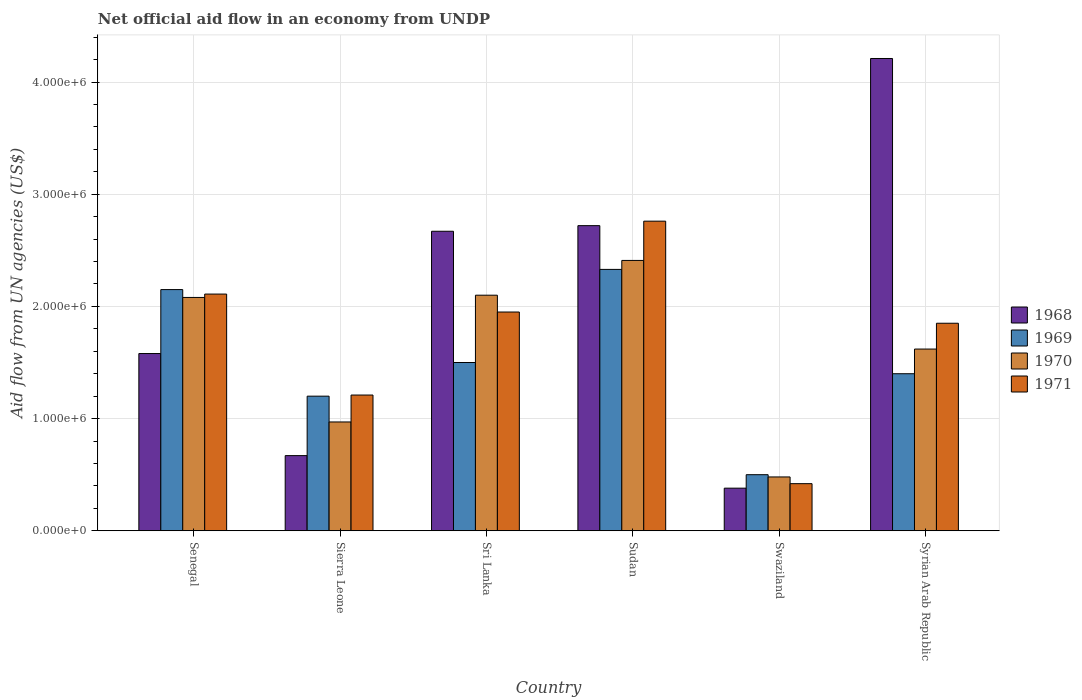Are the number of bars per tick equal to the number of legend labels?
Your response must be concise. Yes. Are the number of bars on each tick of the X-axis equal?
Give a very brief answer. Yes. How many bars are there on the 2nd tick from the left?
Your answer should be very brief. 4. How many bars are there on the 1st tick from the right?
Provide a succinct answer. 4. What is the label of the 5th group of bars from the left?
Keep it short and to the point. Swaziland. In how many cases, is the number of bars for a given country not equal to the number of legend labels?
Offer a very short reply. 0. What is the net official aid flow in 1968 in Syrian Arab Republic?
Keep it short and to the point. 4.21e+06. Across all countries, what is the maximum net official aid flow in 1970?
Give a very brief answer. 2.41e+06. Across all countries, what is the minimum net official aid flow in 1968?
Ensure brevity in your answer.  3.80e+05. In which country was the net official aid flow in 1971 maximum?
Offer a terse response. Sudan. In which country was the net official aid flow in 1971 minimum?
Provide a succinct answer. Swaziland. What is the total net official aid flow in 1968 in the graph?
Ensure brevity in your answer.  1.22e+07. What is the difference between the net official aid flow in 1968 in Sri Lanka and that in Swaziland?
Ensure brevity in your answer.  2.29e+06. What is the difference between the net official aid flow in 1969 in Swaziland and the net official aid flow in 1970 in Sudan?
Your answer should be compact. -1.91e+06. What is the average net official aid flow in 1968 per country?
Make the answer very short. 2.04e+06. What is the difference between the net official aid flow of/in 1970 and net official aid flow of/in 1968 in Swaziland?
Offer a terse response. 1.00e+05. What is the ratio of the net official aid flow in 1970 in Sudan to that in Syrian Arab Republic?
Make the answer very short. 1.49. What is the difference between the highest and the lowest net official aid flow in 1971?
Ensure brevity in your answer.  2.34e+06. In how many countries, is the net official aid flow in 1971 greater than the average net official aid flow in 1971 taken over all countries?
Offer a terse response. 4. What does the 3rd bar from the right in Syrian Arab Republic represents?
Make the answer very short. 1969. Is it the case that in every country, the sum of the net official aid flow in 1971 and net official aid flow in 1970 is greater than the net official aid flow in 1969?
Offer a very short reply. Yes. Are all the bars in the graph horizontal?
Your answer should be very brief. No. Are the values on the major ticks of Y-axis written in scientific E-notation?
Provide a short and direct response. Yes. Does the graph contain grids?
Make the answer very short. Yes. How many legend labels are there?
Offer a very short reply. 4. What is the title of the graph?
Your answer should be compact. Net official aid flow in an economy from UNDP. Does "2014" appear as one of the legend labels in the graph?
Provide a succinct answer. No. What is the label or title of the Y-axis?
Your answer should be compact. Aid flow from UN agencies (US$). What is the Aid flow from UN agencies (US$) in 1968 in Senegal?
Your response must be concise. 1.58e+06. What is the Aid flow from UN agencies (US$) of 1969 in Senegal?
Offer a terse response. 2.15e+06. What is the Aid flow from UN agencies (US$) in 1970 in Senegal?
Your answer should be very brief. 2.08e+06. What is the Aid flow from UN agencies (US$) in 1971 in Senegal?
Your response must be concise. 2.11e+06. What is the Aid flow from UN agencies (US$) of 1968 in Sierra Leone?
Provide a short and direct response. 6.70e+05. What is the Aid flow from UN agencies (US$) of 1969 in Sierra Leone?
Your response must be concise. 1.20e+06. What is the Aid flow from UN agencies (US$) in 1970 in Sierra Leone?
Make the answer very short. 9.70e+05. What is the Aid flow from UN agencies (US$) of 1971 in Sierra Leone?
Your answer should be very brief. 1.21e+06. What is the Aid flow from UN agencies (US$) of 1968 in Sri Lanka?
Your answer should be very brief. 2.67e+06. What is the Aid flow from UN agencies (US$) of 1969 in Sri Lanka?
Provide a short and direct response. 1.50e+06. What is the Aid flow from UN agencies (US$) of 1970 in Sri Lanka?
Ensure brevity in your answer.  2.10e+06. What is the Aid flow from UN agencies (US$) of 1971 in Sri Lanka?
Your answer should be very brief. 1.95e+06. What is the Aid flow from UN agencies (US$) of 1968 in Sudan?
Make the answer very short. 2.72e+06. What is the Aid flow from UN agencies (US$) of 1969 in Sudan?
Provide a succinct answer. 2.33e+06. What is the Aid flow from UN agencies (US$) of 1970 in Sudan?
Keep it short and to the point. 2.41e+06. What is the Aid flow from UN agencies (US$) in 1971 in Sudan?
Your response must be concise. 2.76e+06. What is the Aid flow from UN agencies (US$) of 1968 in Swaziland?
Keep it short and to the point. 3.80e+05. What is the Aid flow from UN agencies (US$) of 1969 in Swaziland?
Give a very brief answer. 5.00e+05. What is the Aid flow from UN agencies (US$) of 1970 in Swaziland?
Keep it short and to the point. 4.80e+05. What is the Aid flow from UN agencies (US$) in 1968 in Syrian Arab Republic?
Your answer should be compact. 4.21e+06. What is the Aid flow from UN agencies (US$) of 1969 in Syrian Arab Republic?
Provide a short and direct response. 1.40e+06. What is the Aid flow from UN agencies (US$) in 1970 in Syrian Arab Republic?
Offer a very short reply. 1.62e+06. What is the Aid flow from UN agencies (US$) in 1971 in Syrian Arab Republic?
Provide a short and direct response. 1.85e+06. Across all countries, what is the maximum Aid flow from UN agencies (US$) of 1968?
Offer a very short reply. 4.21e+06. Across all countries, what is the maximum Aid flow from UN agencies (US$) of 1969?
Give a very brief answer. 2.33e+06. Across all countries, what is the maximum Aid flow from UN agencies (US$) of 1970?
Ensure brevity in your answer.  2.41e+06. Across all countries, what is the maximum Aid flow from UN agencies (US$) of 1971?
Make the answer very short. 2.76e+06. Across all countries, what is the minimum Aid flow from UN agencies (US$) of 1968?
Provide a succinct answer. 3.80e+05. Across all countries, what is the minimum Aid flow from UN agencies (US$) in 1971?
Offer a very short reply. 4.20e+05. What is the total Aid flow from UN agencies (US$) in 1968 in the graph?
Offer a terse response. 1.22e+07. What is the total Aid flow from UN agencies (US$) of 1969 in the graph?
Offer a very short reply. 9.08e+06. What is the total Aid flow from UN agencies (US$) in 1970 in the graph?
Your answer should be very brief. 9.66e+06. What is the total Aid flow from UN agencies (US$) in 1971 in the graph?
Give a very brief answer. 1.03e+07. What is the difference between the Aid flow from UN agencies (US$) in 1968 in Senegal and that in Sierra Leone?
Keep it short and to the point. 9.10e+05. What is the difference between the Aid flow from UN agencies (US$) in 1969 in Senegal and that in Sierra Leone?
Your answer should be compact. 9.50e+05. What is the difference between the Aid flow from UN agencies (US$) of 1970 in Senegal and that in Sierra Leone?
Make the answer very short. 1.11e+06. What is the difference between the Aid flow from UN agencies (US$) in 1971 in Senegal and that in Sierra Leone?
Your answer should be compact. 9.00e+05. What is the difference between the Aid flow from UN agencies (US$) in 1968 in Senegal and that in Sri Lanka?
Ensure brevity in your answer.  -1.09e+06. What is the difference between the Aid flow from UN agencies (US$) of 1969 in Senegal and that in Sri Lanka?
Offer a very short reply. 6.50e+05. What is the difference between the Aid flow from UN agencies (US$) in 1968 in Senegal and that in Sudan?
Your response must be concise. -1.14e+06. What is the difference between the Aid flow from UN agencies (US$) in 1970 in Senegal and that in Sudan?
Your answer should be compact. -3.30e+05. What is the difference between the Aid flow from UN agencies (US$) of 1971 in Senegal and that in Sudan?
Offer a terse response. -6.50e+05. What is the difference between the Aid flow from UN agencies (US$) of 1968 in Senegal and that in Swaziland?
Your answer should be very brief. 1.20e+06. What is the difference between the Aid flow from UN agencies (US$) in 1969 in Senegal and that in Swaziland?
Your answer should be very brief. 1.65e+06. What is the difference between the Aid flow from UN agencies (US$) in 1970 in Senegal and that in Swaziland?
Your answer should be very brief. 1.60e+06. What is the difference between the Aid flow from UN agencies (US$) in 1971 in Senegal and that in Swaziland?
Your answer should be very brief. 1.69e+06. What is the difference between the Aid flow from UN agencies (US$) in 1968 in Senegal and that in Syrian Arab Republic?
Provide a short and direct response. -2.63e+06. What is the difference between the Aid flow from UN agencies (US$) of 1969 in Senegal and that in Syrian Arab Republic?
Your answer should be very brief. 7.50e+05. What is the difference between the Aid flow from UN agencies (US$) in 1970 in Senegal and that in Syrian Arab Republic?
Ensure brevity in your answer.  4.60e+05. What is the difference between the Aid flow from UN agencies (US$) of 1971 in Senegal and that in Syrian Arab Republic?
Provide a succinct answer. 2.60e+05. What is the difference between the Aid flow from UN agencies (US$) of 1968 in Sierra Leone and that in Sri Lanka?
Provide a succinct answer. -2.00e+06. What is the difference between the Aid flow from UN agencies (US$) of 1969 in Sierra Leone and that in Sri Lanka?
Your response must be concise. -3.00e+05. What is the difference between the Aid flow from UN agencies (US$) in 1970 in Sierra Leone and that in Sri Lanka?
Your answer should be compact. -1.13e+06. What is the difference between the Aid flow from UN agencies (US$) in 1971 in Sierra Leone and that in Sri Lanka?
Give a very brief answer. -7.40e+05. What is the difference between the Aid flow from UN agencies (US$) in 1968 in Sierra Leone and that in Sudan?
Your answer should be compact. -2.05e+06. What is the difference between the Aid flow from UN agencies (US$) of 1969 in Sierra Leone and that in Sudan?
Make the answer very short. -1.13e+06. What is the difference between the Aid flow from UN agencies (US$) of 1970 in Sierra Leone and that in Sudan?
Provide a succinct answer. -1.44e+06. What is the difference between the Aid flow from UN agencies (US$) of 1971 in Sierra Leone and that in Sudan?
Your answer should be very brief. -1.55e+06. What is the difference between the Aid flow from UN agencies (US$) of 1971 in Sierra Leone and that in Swaziland?
Offer a very short reply. 7.90e+05. What is the difference between the Aid flow from UN agencies (US$) of 1968 in Sierra Leone and that in Syrian Arab Republic?
Ensure brevity in your answer.  -3.54e+06. What is the difference between the Aid flow from UN agencies (US$) of 1970 in Sierra Leone and that in Syrian Arab Republic?
Ensure brevity in your answer.  -6.50e+05. What is the difference between the Aid flow from UN agencies (US$) of 1971 in Sierra Leone and that in Syrian Arab Republic?
Provide a succinct answer. -6.40e+05. What is the difference between the Aid flow from UN agencies (US$) in 1968 in Sri Lanka and that in Sudan?
Your answer should be compact. -5.00e+04. What is the difference between the Aid flow from UN agencies (US$) of 1969 in Sri Lanka and that in Sudan?
Ensure brevity in your answer.  -8.30e+05. What is the difference between the Aid flow from UN agencies (US$) of 1970 in Sri Lanka and that in Sudan?
Offer a very short reply. -3.10e+05. What is the difference between the Aid flow from UN agencies (US$) of 1971 in Sri Lanka and that in Sudan?
Provide a short and direct response. -8.10e+05. What is the difference between the Aid flow from UN agencies (US$) in 1968 in Sri Lanka and that in Swaziland?
Offer a very short reply. 2.29e+06. What is the difference between the Aid flow from UN agencies (US$) in 1969 in Sri Lanka and that in Swaziland?
Give a very brief answer. 1.00e+06. What is the difference between the Aid flow from UN agencies (US$) in 1970 in Sri Lanka and that in Swaziland?
Provide a short and direct response. 1.62e+06. What is the difference between the Aid flow from UN agencies (US$) in 1971 in Sri Lanka and that in Swaziland?
Your answer should be very brief. 1.53e+06. What is the difference between the Aid flow from UN agencies (US$) in 1968 in Sri Lanka and that in Syrian Arab Republic?
Give a very brief answer. -1.54e+06. What is the difference between the Aid flow from UN agencies (US$) in 1970 in Sri Lanka and that in Syrian Arab Republic?
Give a very brief answer. 4.80e+05. What is the difference between the Aid flow from UN agencies (US$) of 1968 in Sudan and that in Swaziland?
Give a very brief answer. 2.34e+06. What is the difference between the Aid flow from UN agencies (US$) of 1969 in Sudan and that in Swaziland?
Provide a succinct answer. 1.83e+06. What is the difference between the Aid flow from UN agencies (US$) in 1970 in Sudan and that in Swaziland?
Your answer should be compact. 1.93e+06. What is the difference between the Aid flow from UN agencies (US$) of 1971 in Sudan and that in Swaziland?
Provide a succinct answer. 2.34e+06. What is the difference between the Aid flow from UN agencies (US$) in 1968 in Sudan and that in Syrian Arab Republic?
Keep it short and to the point. -1.49e+06. What is the difference between the Aid flow from UN agencies (US$) of 1969 in Sudan and that in Syrian Arab Republic?
Provide a succinct answer. 9.30e+05. What is the difference between the Aid flow from UN agencies (US$) of 1970 in Sudan and that in Syrian Arab Republic?
Your answer should be compact. 7.90e+05. What is the difference between the Aid flow from UN agencies (US$) in 1971 in Sudan and that in Syrian Arab Republic?
Ensure brevity in your answer.  9.10e+05. What is the difference between the Aid flow from UN agencies (US$) of 1968 in Swaziland and that in Syrian Arab Republic?
Provide a short and direct response. -3.83e+06. What is the difference between the Aid flow from UN agencies (US$) in 1969 in Swaziland and that in Syrian Arab Republic?
Offer a very short reply. -9.00e+05. What is the difference between the Aid flow from UN agencies (US$) of 1970 in Swaziland and that in Syrian Arab Republic?
Give a very brief answer. -1.14e+06. What is the difference between the Aid flow from UN agencies (US$) of 1971 in Swaziland and that in Syrian Arab Republic?
Provide a succinct answer. -1.43e+06. What is the difference between the Aid flow from UN agencies (US$) of 1968 in Senegal and the Aid flow from UN agencies (US$) of 1969 in Sierra Leone?
Give a very brief answer. 3.80e+05. What is the difference between the Aid flow from UN agencies (US$) of 1968 in Senegal and the Aid flow from UN agencies (US$) of 1970 in Sierra Leone?
Your response must be concise. 6.10e+05. What is the difference between the Aid flow from UN agencies (US$) of 1969 in Senegal and the Aid flow from UN agencies (US$) of 1970 in Sierra Leone?
Provide a succinct answer. 1.18e+06. What is the difference between the Aid flow from UN agencies (US$) of 1969 in Senegal and the Aid flow from UN agencies (US$) of 1971 in Sierra Leone?
Your response must be concise. 9.40e+05. What is the difference between the Aid flow from UN agencies (US$) in 1970 in Senegal and the Aid flow from UN agencies (US$) in 1971 in Sierra Leone?
Your response must be concise. 8.70e+05. What is the difference between the Aid flow from UN agencies (US$) in 1968 in Senegal and the Aid flow from UN agencies (US$) in 1969 in Sri Lanka?
Ensure brevity in your answer.  8.00e+04. What is the difference between the Aid flow from UN agencies (US$) of 1968 in Senegal and the Aid flow from UN agencies (US$) of 1970 in Sri Lanka?
Provide a short and direct response. -5.20e+05. What is the difference between the Aid flow from UN agencies (US$) of 1968 in Senegal and the Aid flow from UN agencies (US$) of 1971 in Sri Lanka?
Provide a succinct answer. -3.70e+05. What is the difference between the Aid flow from UN agencies (US$) in 1969 in Senegal and the Aid flow from UN agencies (US$) in 1970 in Sri Lanka?
Provide a short and direct response. 5.00e+04. What is the difference between the Aid flow from UN agencies (US$) of 1969 in Senegal and the Aid flow from UN agencies (US$) of 1971 in Sri Lanka?
Keep it short and to the point. 2.00e+05. What is the difference between the Aid flow from UN agencies (US$) in 1970 in Senegal and the Aid flow from UN agencies (US$) in 1971 in Sri Lanka?
Make the answer very short. 1.30e+05. What is the difference between the Aid flow from UN agencies (US$) in 1968 in Senegal and the Aid flow from UN agencies (US$) in 1969 in Sudan?
Make the answer very short. -7.50e+05. What is the difference between the Aid flow from UN agencies (US$) of 1968 in Senegal and the Aid flow from UN agencies (US$) of 1970 in Sudan?
Provide a short and direct response. -8.30e+05. What is the difference between the Aid flow from UN agencies (US$) in 1968 in Senegal and the Aid flow from UN agencies (US$) in 1971 in Sudan?
Your answer should be compact. -1.18e+06. What is the difference between the Aid flow from UN agencies (US$) in 1969 in Senegal and the Aid flow from UN agencies (US$) in 1971 in Sudan?
Offer a very short reply. -6.10e+05. What is the difference between the Aid flow from UN agencies (US$) of 1970 in Senegal and the Aid flow from UN agencies (US$) of 1971 in Sudan?
Your response must be concise. -6.80e+05. What is the difference between the Aid flow from UN agencies (US$) of 1968 in Senegal and the Aid flow from UN agencies (US$) of 1969 in Swaziland?
Your answer should be compact. 1.08e+06. What is the difference between the Aid flow from UN agencies (US$) in 1968 in Senegal and the Aid flow from UN agencies (US$) in 1970 in Swaziland?
Your response must be concise. 1.10e+06. What is the difference between the Aid flow from UN agencies (US$) in 1968 in Senegal and the Aid flow from UN agencies (US$) in 1971 in Swaziland?
Your answer should be very brief. 1.16e+06. What is the difference between the Aid flow from UN agencies (US$) in 1969 in Senegal and the Aid flow from UN agencies (US$) in 1970 in Swaziland?
Offer a very short reply. 1.67e+06. What is the difference between the Aid flow from UN agencies (US$) in 1969 in Senegal and the Aid flow from UN agencies (US$) in 1971 in Swaziland?
Your answer should be very brief. 1.73e+06. What is the difference between the Aid flow from UN agencies (US$) of 1970 in Senegal and the Aid flow from UN agencies (US$) of 1971 in Swaziland?
Keep it short and to the point. 1.66e+06. What is the difference between the Aid flow from UN agencies (US$) of 1968 in Senegal and the Aid flow from UN agencies (US$) of 1971 in Syrian Arab Republic?
Offer a very short reply. -2.70e+05. What is the difference between the Aid flow from UN agencies (US$) of 1969 in Senegal and the Aid flow from UN agencies (US$) of 1970 in Syrian Arab Republic?
Keep it short and to the point. 5.30e+05. What is the difference between the Aid flow from UN agencies (US$) in 1969 in Senegal and the Aid flow from UN agencies (US$) in 1971 in Syrian Arab Republic?
Offer a terse response. 3.00e+05. What is the difference between the Aid flow from UN agencies (US$) of 1970 in Senegal and the Aid flow from UN agencies (US$) of 1971 in Syrian Arab Republic?
Offer a terse response. 2.30e+05. What is the difference between the Aid flow from UN agencies (US$) of 1968 in Sierra Leone and the Aid flow from UN agencies (US$) of 1969 in Sri Lanka?
Your answer should be very brief. -8.30e+05. What is the difference between the Aid flow from UN agencies (US$) in 1968 in Sierra Leone and the Aid flow from UN agencies (US$) in 1970 in Sri Lanka?
Provide a succinct answer. -1.43e+06. What is the difference between the Aid flow from UN agencies (US$) in 1968 in Sierra Leone and the Aid flow from UN agencies (US$) in 1971 in Sri Lanka?
Provide a short and direct response. -1.28e+06. What is the difference between the Aid flow from UN agencies (US$) in 1969 in Sierra Leone and the Aid flow from UN agencies (US$) in 1970 in Sri Lanka?
Your response must be concise. -9.00e+05. What is the difference between the Aid flow from UN agencies (US$) in 1969 in Sierra Leone and the Aid flow from UN agencies (US$) in 1971 in Sri Lanka?
Give a very brief answer. -7.50e+05. What is the difference between the Aid flow from UN agencies (US$) of 1970 in Sierra Leone and the Aid flow from UN agencies (US$) of 1971 in Sri Lanka?
Give a very brief answer. -9.80e+05. What is the difference between the Aid flow from UN agencies (US$) of 1968 in Sierra Leone and the Aid flow from UN agencies (US$) of 1969 in Sudan?
Provide a succinct answer. -1.66e+06. What is the difference between the Aid flow from UN agencies (US$) of 1968 in Sierra Leone and the Aid flow from UN agencies (US$) of 1970 in Sudan?
Your response must be concise. -1.74e+06. What is the difference between the Aid flow from UN agencies (US$) of 1968 in Sierra Leone and the Aid flow from UN agencies (US$) of 1971 in Sudan?
Provide a succinct answer. -2.09e+06. What is the difference between the Aid flow from UN agencies (US$) of 1969 in Sierra Leone and the Aid flow from UN agencies (US$) of 1970 in Sudan?
Your response must be concise. -1.21e+06. What is the difference between the Aid flow from UN agencies (US$) of 1969 in Sierra Leone and the Aid flow from UN agencies (US$) of 1971 in Sudan?
Make the answer very short. -1.56e+06. What is the difference between the Aid flow from UN agencies (US$) of 1970 in Sierra Leone and the Aid flow from UN agencies (US$) of 1971 in Sudan?
Your answer should be compact. -1.79e+06. What is the difference between the Aid flow from UN agencies (US$) in 1968 in Sierra Leone and the Aid flow from UN agencies (US$) in 1971 in Swaziland?
Provide a succinct answer. 2.50e+05. What is the difference between the Aid flow from UN agencies (US$) in 1969 in Sierra Leone and the Aid flow from UN agencies (US$) in 1970 in Swaziland?
Offer a very short reply. 7.20e+05. What is the difference between the Aid flow from UN agencies (US$) of 1969 in Sierra Leone and the Aid flow from UN agencies (US$) of 1971 in Swaziland?
Offer a very short reply. 7.80e+05. What is the difference between the Aid flow from UN agencies (US$) of 1968 in Sierra Leone and the Aid flow from UN agencies (US$) of 1969 in Syrian Arab Republic?
Make the answer very short. -7.30e+05. What is the difference between the Aid flow from UN agencies (US$) in 1968 in Sierra Leone and the Aid flow from UN agencies (US$) in 1970 in Syrian Arab Republic?
Ensure brevity in your answer.  -9.50e+05. What is the difference between the Aid flow from UN agencies (US$) in 1968 in Sierra Leone and the Aid flow from UN agencies (US$) in 1971 in Syrian Arab Republic?
Offer a very short reply. -1.18e+06. What is the difference between the Aid flow from UN agencies (US$) of 1969 in Sierra Leone and the Aid flow from UN agencies (US$) of 1970 in Syrian Arab Republic?
Ensure brevity in your answer.  -4.20e+05. What is the difference between the Aid flow from UN agencies (US$) of 1969 in Sierra Leone and the Aid flow from UN agencies (US$) of 1971 in Syrian Arab Republic?
Your response must be concise. -6.50e+05. What is the difference between the Aid flow from UN agencies (US$) of 1970 in Sierra Leone and the Aid flow from UN agencies (US$) of 1971 in Syrian Arab Republic?
Ensure brevity in your answer.  -8.80e+05. What is the difference between the Aid flow from UN agencies (US$) of 1968 in Sri Lanka and the Aid flow from UN agencies (US$) of 1969 in Sudan?
Your response must be concise. 3.40e+05. What is the difference between the Aid flow from UN agencies (US$) in 1969 in Sri Lanka and the Aid flow from UN agencies (US$) in 1970 in Sudan?
Keep it short and to the point. -9.10e+05. What is the difference between the Aid flow from UN agencies (US$) in 1969 in Sri Lanka and the Aid flow from UN agencies (US$) in 1971 in Sudan?
Ensure brevity in your answer.  -1.26e+06. What is the difference between the Aid flow from UN agencies (US$) of 1970 in Sri Lanka and the Aid flow from UN agencies (US$) of 1971 in Sudan?
Provide a succinct answer. -6.60e+05. What is the difference between the Aid flow from UN agencies (US$) in 1968 in Sri Lanka and the Aid flow from UN agencies (US$) in 1969 in Swaziland?
Offer a very short reply. 2.17e+06. What is the difference between the Aid flow from UN agencies (US$) of 1968 in Sri Lanka and the Aid flow from UN agencies (US$) of 1970 in Swaziland?
Make the answer very short. 2.19e+06. What is the difference between the Aid flow from UN agencies (US$) of 1968 in Sri Lanka and the Aid flow from UN agencies (US$) of 1971 in Swaziland?
Ensure brevity in your answer.  2.25e+06. What is the difference between the Aid flow from UN agencies (US$) in 1969 in Sri Lanka and the Aid flow from UN agencies (US$) in 1970 in Swaziland?
Your response must be concise. 1.02e+06. What is the difference between the Aid flow from UN agencies (US$) of 1969 in Sri Lanka and the Aid flow from UN agencies (US$) of 1971 in Swaziland?
Provide a succinct answer. 1.08e+06. What is the difference between the Aid flow from UN agencies (US$) in 1970 in Sri Lanka and the Aid flow from UN agencies (US$) in 1971 in Swaziland?
Offer a very short reply. 1.68e+06. What is the difference between the Aid flow from UN agencies (US$) of 1968 in Sri Lanka and the Aid flow from UN agencies (US$) of 1969 in Syrian Arab Republic?
Give a very brief answer. 1.27e+06. What is the difference between the Aid flow from UN agencies (US$) of 1968 in Sri Lanka and the Aid flow from UN agencies (US$) of 1970 in Syrian Arab Republic?
Provide a short and direct response. 1.05e+06. What is the difference between the Aid flow from UN agencies (US$) in 1968 in Sri Lanka and the Aid flow from UN agencies (US$) in 1971 in Syrian Arab Republic?
Your response must be concise. 8.20e+05. What is the difference between the Aid flow from UN agencies (US$) of 1969 in Sri Lanka and the Aid flow from UN agencies (US$) of 1970 in Syrian Arab Republic?
Your response must be concise. -1.20e+05. What is the difference between the Aid flow from UN agencies (US$) of 1969 in Sri Lanka and the Aid flow from UN agencies (US$) of 1971 in Syrian Arab Republic?
Provide a succinct answer. -3.50e+05. What is the difference between the Aid flow from UN agencies (US$) in 1968 in Sudan and the Aid flow from UN agencies (US$) in 1969 in Swaziland?
Offer a terse response. 2.22e+06. What is the difference between the Aid flow from UN agencies (US$) in 1968 in Sudan and the Aid flow from UN agencies (US$) in 1970 in Swaziland?
Keep it short and to the point. 2.24e+06. What is the difference between the Aid flow from UN agencies (US$) in 1968 in Sudan and the Aid flow from UN agencies (US$) in 1971 in Swaziland?
Give a very brief answer. 2.30e+06. What is the difference between the Aid flow from UN agencies (US$) of 1969 in Sudan and the Aid flow from UN agencies (US$) of 1970 in Swaziland?
Your answer should be very brief. 1.85e+06. What is the difference between the Aid flow from UN agencies (US$) of 1969 in Sudan and the Aid flow from UN agencies (US$) of 1971 in Swaziland?
Give a very brief answer. 1.91e+06. What is the difference between the Aid flow from UN agencies (US$) in 1970 in Sudan and the Aid flow from UN agencies (US$) in 1971 in Swaziland?
Provide a short and direct response. 1.99e+06. What is the difference between the Aid flow from UN agencies (US$) of 1968 in Sudan and the Aid flow from UN agencies (US$) of 1969 in Syrian Arab Republic?
Provide a short and direct response. 1.32e+06. What is the difference between the Aid flow from UN agencies (US$) of 1968 in Sudan and the Aid flow from UN agencies (US$) of 1970 in Syrian Arab Republic?
Make the answer very short. 1.10e+06. What is the difference between the Aid flow from UN agencies (US$) of 1968 in Sudan and the Aid flow from UN agencies (US$) of 1971 in Syrian Arab Republic?
Your answer should be compact. 8.70e+05. What is the difference between the Aid flow from UN agencies (US$) of 1969 in Sudan and the Aid flow from UN agencies (US$) of 1970 in Syrian Arab Republic?
Make the answer very short. 7.10e+05. What is the difference between the Aid flow from UN agencies (US$) of 1969 in Sudan and the Aid flow from UN agencies (US$) of 1971 in Syrian Arab Republic?
Offer a very short reply. 4.80e+05. What is the difference between the Aid flow from UN agencies (US$) in 1970 in Sudan and the Aid flow from UN agencies (US$) in 1971 in Syrian Arab Republic?
Your response must be concise. 5.60e+05. What is the difference between the Aid flow from UN agencies (US$) of 1968 in Swaziland and the Aid flow from UN agencies (US$) of 1969 in Syrian Arab Republic?
Your answer should be very brief. -1.02e+06. What is the difference between the Aid flow from UN agencies (US$) in 1968 in Swaziland and the Aid flow from UN agencies (US$) in 1970 in Syrian Arab Republic?
Make the answer very short. -1.24e+06. What is the difference between the Aid flow from UN agencies (US$) of 1968 in Swaziland and the Aid flow from UN agencies (US$) of 1971 in Syrian Arab Republic?
Your answer should be compact. -1.47e+06. What is the difference between the Aid flow from UN agencies (US$) in 1969 in Swaziland and the Aid flow from UN agencies (US$) in 1970 in Syrian Arab Republic?
Give a very brief answer. -1.12e+06. What is the difference between the Aid flow from UN agencies (US$) of 1969 in Swaziland and the Aid flow from UN agencies (US$) of 1971 in Syrian Arab Republic?
Make the answer very short. -1.35e+06. What is the difference between the Aid flow from UN agencies (US$) in 1970 in Swaziland and the Aid flow from UN agencies (US$) in 1971 in Syrian Arab Republic?
Offer a terse response. -1.37e+06. What is the average Aid flow from UN agencies (US$) in 1968 per country?
Provide a succinct answer. 2.04e+06. What is the average Aid flow from UN agencies (US$) in 1969 per country?
Offer a very short reply. 1.51e+06. What is the average Aid flow from UN agencies (US$) of 1970 per country?
Provide a succinct answer. 1.61e+06. What is the average Aid flow from UN agencies (US$) in 1971 per country?
Your response must be concise. 1.72e+06. What is the difference between the Aid flow from UN agencies (US$) in 1968 and Aid flow from UN agencies (US$) in 1969 in Senegal?
Provide a short and direct response. -5.70e+05. What is the difference between the Aid flow from UN agencies (US$) in 1968 and Aid flow from UN agencies (US$) in 1970 in Senegal?
Your answer should be compact. -5.00e+05. What is the difference between the Aid flow from UN agencies (US$) of 1968 and Aid flow from UN agencies (US$) of 1971 in Senegal?
Offer a terse response. -5.30e+05. What is the difference between the Aid flow from UN agencies (US$) in 1969 and Aid flow from UN agencies (US$) in 1971 in Senegal?
Ensure brevity in your answer.  4.00e+04. What is the difference between the Aid flow from UN agencies (US$) of 1968 and Aid flow from UN agencies (US$) of 1969 in Sierra Leone?
Your answer should be very brief. -5.30e+05. What is the difference between the Aid flow from UN agencies (US$) in 1968 and Aid flow from UN agencies (US$) in 1971 in Sierra Leone?
Provide a short and direct response. -5.40e+05. What is the difference between the Aid flow from UN agencies (US$) in 1969 and Aid flow from UN agencies (US$) in 1970 in Sierra Leone?
Provide a short and direct response. 2.30e+05. What is the difference between the Aid flow from UN agencies (US$) in 1970 and Aid flow from UN agencies (US$) in 1971 in Sierra Leone?
Give a very brief answer. -2.40e+05. What is the difference between the Aid flow from UN agencies (US$) of 1968 and Aid flow from UN agencies (US$) of 1969 in Sri Lanka?
Provide a short and direct response. 1.17e+06. What is the difference between the Aid flow from UN agencies (US$) of 1968 and Aid flow from UN agencies (US$) of 1970 in Sri Lanka?
Ensure brevity in your answer.  5.70e+05. What is the difference between the Aid flow from UN agencies (US$) in 1968 and Aid flow from UN agencies (US$) in 1971 in Sri Lanka?
Give a very brief answer. 7.20e+05. What is the difference between the Aid flow from UN agencies (US$) in 1969 and Aid flow from UN agencies (US$) in 1970 in Sri Lanka?
Offer a terse response. -6.00e+05. What is the difference between the Aid flow from UN agencies (US$) of 1969 and Aid flow from UN agencies (US$) of 1971 in Sri Lanka?
Your answer should be compact. -4.50e+05. What is the difference between the Aid flow from UN agencies (US$) of 1968 and Aid flow from UN agencies (US$) of 1970 in Sudan?
Offer a terse response. 3.10e+05. What is the difference between the Aid flow from UN agencies (US$) in 1969 and Aid flow from UN agencies (US$) in 1971 in Sudan?
Your answer should be compact. -4.30e+05. What is the difference between the Aid flow from UN agencies (US$) in 1970 and Aid flow from UN agencies (US$) in 1971 in Sudan?
Your answer should be compact. -3.50e+05. What is the difference between the Aid flow from UN agencies (US$) of 1968 and Aid flow from UN agencies (US$) of 1970 in Swaziland?
Keep it short and to the point. -1.00e+05. What is the difference between the Aid flow from UN agencies (US$) of 1968 and Aid flow from UN agencies (US$) of 1971 in Swaziland?
Offer a very short reply. -4.00e+04. What is the difference between the Aid flow from UN agencies (US$) in 1969 and Aid flow from UN agencies (US$) in 1970 in Swaziland?
Make the answer very short. 2.00e+04. What is the difference between the Aid flow from UN agencies (US$) in 1968 and Aid flow from UN agencies (US$) in 1969 in Syrian Arab Republic?
Your response must be concise. 2.81e+06. What is the difference between the Aid flow from UN agencies (US$) in 1968 and Aid flow from UN agencies (US$) in 1970 in Syrian Arab Republic?
Keep it short and to the point. 2.59e+06. What is the difference between the Aid flow from UN agencies (US$) of 1968 and Aid flow from UN agencies (US$) of 1971 in Syrian Arab Republic?
Offer a very short reply. 2.36e+06. What is the difference between the Aid flow from UN agencies (US$) in 1969 and Aid flow from UN agencies (US$) in 1971 in Syrian Arab Republic?
Your response must be concise. -4.50e+05. What is the ratio of the Aid flow from UN agencies (US$) of 1968 in Senegal to that in Sierra Leone?
Offer a very short reply. 2.36. What is the ratio of the Aid flow from UN agencies (US$) of 1969 in Senegal to that in Sierra Leone?
Your response must be concise. 1.79. What is the ratio of the Aid flow from UN agencies (US$) in 1970 in Senegal to that in Sierra Leone?
Provide a succinct answer. 2.14. What is the ratio of the Aid flow from UN agencies (US$) of 1971 in Senegal to that in Sierra Leone?
Provide a succinct answer. 1.74. What is the ratio of the Aid flow from UN agencies (US$) in 1968 in Senegal to that in Sri Lanka?
Provide a short and direct response. 0.59. What is the ratio of the Aid flow from UN agencies (US$) of 1969 in Senegal to that in Sri Lanka?
Your answer should be very brief. 1.43. What is the ratio of the Aid flow from UN agencies (US$) of 1970 in Senegal to that in Sri Lanka?
Ensure brevity in your answer.  0.99. What is the ratio of the Aid flow from UN agencies (US$) of 1971 in Senegal to that in Sri Lanka?
Provide a short and direct response. 1.08. What is the ratio of the Aid flow from UN agencies (US$) of 1968 in Senegal to that in Sudan?
Give a very brief answer. 0.58. What is the ratio of the Aid flow from UN agencies (US$) of 1969 in Senegal to that in Sudan?
Give a very brief answer. 0.92. What is the ratio of the Aid flow from UN agencies (US$) of 1970 in Senegal to that in Sudan?
Provide a short and direct response. 0.86. What is the ratio of the Aid flow from UN agencies (US$) of 1971 in Senegal to that in Sudan?
Offer a terse response. 0.76. What is the ratio of the Aid flow from UN agencies (US$) in 1968 in Senegal to that in Swaziland?
Provide a succinct answer. 4.16. What is the ratio of the Aid flow from UN agencies (US$) in 1970 in Senegal to that in Swaziland?
Ensure brevity in your answer.  4.33. What is the ratio of the Aid flow from UN agencies (US$) of 1971 in Senegal to that in Swaziland?
Give a very brief answer. 5.02. What is the ratio of the Aid flow from UN agencies (US$) of 1968 in Senegal to that in Syrian Arab Republic?
Your response must be concise. 0.38. What is the ratio of the Aid flow from UN agencies (US$) in 1969 in Senegal to that in Syrian Arab Republic?
Keep it short and to the point. 1.54. What is the ratio of the Aid flow from UN agencies (US$) of 1970 in Senegal to that in Syrian Arab Republic?
Provide a short and direct response. 1.28. What is the ratio of the Aid flow from UN agencies (US$) in 1971 in Senegal to that in Syrian Arab Republic?
Ensure brevity in your answer.  1.14. What is the ratio of the Aid flow from UN agencies (US$) in 1968 in Sierra Leone to that in Sri Lanka?
Offer a terse response. 0.25. What is the ratio of the Aid flow from UN agencies (US$) in 1970 in Sierra Leone to that in Sri Lanka?
Ensure brevity in your answer.  0.46. What is the ratio of the Aid flow from UN agencies (US$) in 1971 in Sierra Leone to that in Sri Lanka?
Give a very brief answer. 0.62. What is the ratio of the Aid flow from UN agencies (US$) in 1968 in Sierra Leone to that in Sudan?
Provide a succinct answer. 0.25. What is the ratio of the Aid flow from UN agencies (US$) in 1969 in Sierra Leone to that in Sudan?
Offer a terse response. 0.52. What is the ratio of the Aid flow from UN agencies (US$) in 1970 in Sierra Leone to that in Sudan?
Your response must be concise. 0.4. What is the ratio of the Aid flow from UN agencies (US$) of 1971 in Sierra Leone to that in Sudan?
Your response must be concise. 0.44. What is the ratio of the Aid flow from UN agencies (US$) of 1968 in Sierra Leone to that in Swaziland?
Your answer should be very brief. 1.76. What is the ratio of the Aid flow from UN agencies (US$) of 1969 in Sierra Leone to that in Swaziland?
Keep it short and to the point. 2.4. What is the ratio of the Aid flow from UN agencies (US$) of 1970 in Sierra Leone to that in Swaziland?
Provide a short and direct response. 2.02. What is the ratio of the Aid flow from UN agencies (US$) in 1971 in Sierra Leone to that in Swaziland?
Offer a terse response. 2.88. What is the ratio of the Aid flow from UN agencies (US$) in 1968 in Sierra Leone to that in Syrian Arab Republic?
Offer a very short reply. 0.16. What is the ratio of the Aid flow from UN agencies (US$) in 1970 in Sierra Leone to that in Syrian Arab Republic?
Your response must be concise. 0.6. What is the ratio of the Aid flow from UN agencies (US$) of 1971 in Sierra Leone to that in Syrian Arab Republic?
Your answer should be compact. 0.65. What is the ratio of the Aid flow from UN agencies (US$) of 1968 in Sri Lanka to that in Sudan?
Ensure brevity in your answer.  0.98. What is the ratio of the Aid flow from UN agencies (US$) in 1969 in Sri Lanka to that in Sudan?
Your answer should be very brief. 0.64. What is the ratio of the Aid flow from UN agencies (US$) of 1970 in Sri Lanka to that in Sudan?
Offer a terse response. 0.87. What is the ratio of the Aid flow from UN agencies (US$) in 1971 in Sri Lanka to that in Sudan?
Ensure brevity in your answer.  0.71. What is the ratio of the Aid flow from UN agencies (US$) of 1968 in Sri Lanka to that in Swaziland?
Your response must be concise. 7.03. What is the ratio of the Aid flow from UN agencies (US$) of 1969 in Sri Lanka to that in Swaziland?
Offer a terse response. 3. What is the ratio of the Aid flow from UN agencies (US$) in 1970 in Sri Lanka to that in Swaziland?
Offer a very short reply. 4.38. What is the ratio of the Aid flow from UN agencies (US$) in 1971 in Sri Lanka to that in Swaziland?
Give a very brief answer. 4.64. What is the ratio of the Aid flow from UN agencies (US$) in 1968 in Sri Lanka to that in Syrian Arab Republic?
Keep it short and to the point. 0.63. What is the ratio of the Aid flow from UN agencies (US$) of 1969 in Sri Lanka to that in Syrian Arab Republic?
Provide a succinct answer. 1.07. What is the ratio of the Aid flow from UN agencies (US$) in 1970 in Sri Lanka to that in Syrian Arab Republic?
Make the answer very short. 1.3. What is the ratio of the Aid flow from UN agencies (US$) of 1971 in Sri Lanka to that in Syrian Arab Republic?
Provide a succinct answer. 1.05. What is the ratio of the Aid flow from UN agencies (US$) in 1968 in Sudan to that in Swaziland?
Make the answer very short. 7.16. What is the ratio of the Aid flow from UN agencies (US$) of 1969 in Sudan to that in Swaziland?
Your answer should be very brief. 4.66. What is the ratio of the Aid flow from UN agencies (US$) in 1970 in Sudan to that in Swaziland?
Your answer should be very brief. 5.02. What is the ratio of the Aid flow from UN agencies (US$) of 1971 in Sudan to that in Swaziland?
Provide a succinct answer. 6.57. What is the ratio of the Aid flow from UN agencies (US$) of 1968 in Sudan to that in Syrian Arab Republic?
Offer a terse response. 0.65. What is the ratio of the Aid flow from UN agencies (US$) of 1969 in Sudan to that in Syrian Arab Republic?
Offer a very short reply. 1.66. What is the ratio of the Aid flow from UN agencies (US$) of 1970 in Sudan to that in Syrian Arab Republic?
Make the answer very short. 1.49. What is the ratio of the Aid flow from UN agencies (US$) in 1971 in Sudan to that in Syrian Arab Republic?
Make the answer very short. 1.49. What is the ratio of the Aid flow from UN agencies (US$) in 1968 in Swaziland to that in Syrian Arab Republic?
Keep it short and to the point. 0.09. What is the ratio of the Aid flow from UN agencies (US$) in 1969 in Swaziland to that in Syrian Arab Republic?
Your answer should be very brief. 0.36. What is the ratio of the Aid flow from UN agencies (US$) of 1970 in Swaziland to that in Syrian Arab Republic?
Provide a short and direct response. 0.3. What is the ratio of the Aid flow from UN agencies (US$) in 1971 in Swaziland to that in Syrian Arab Republic?
Your answer should be compact. 0.23. What is the difference between the highest and the second highest Aid flow from UN agencies (US$) of 1968?
Provide a succinct answer. 1.49e+06. What is the difference between the highest and the second highest Aid flow from UN agencies (US$) in 1971?
Offer a very short reply. 6.50e+05. What is the difference between the highest and the lowest Aid flow from UN agencies (US$) in 1968?
Keep it short and to the point. 3.83e+06. What is the difference between the highest and the lowest Aid flow from UN agencies (US$) in 1969?
Your response must be concise. 1.83e+06. What is the difference between the highest and the lowest Aid flow from UN agencies (US$) of 1970?
Your answer should be compact. 1.93e+06. What is the difference between the highest and the lowest Aid flow from UN agencies (US$) of 1971?
Keep it short and to the point. 2.34e+06. 